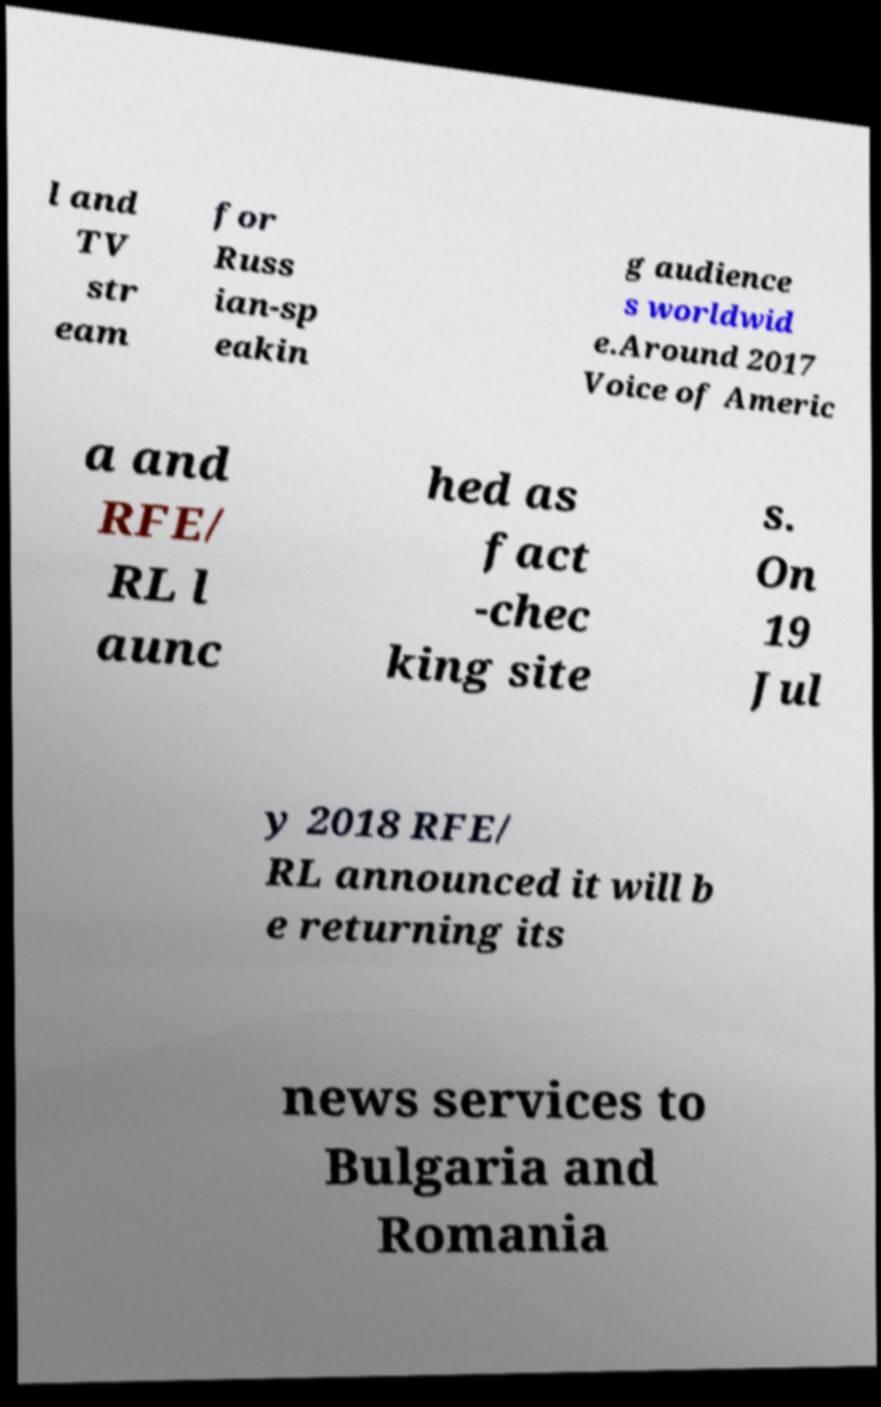Please read and relay the text visible in this image. What does it say? l and TV str eam for Russ ian-sp eakin g audience s worldwid e.Around 2017 Voice of Americ a and RFE/ RL l aunc hed as fact -chec king site s. On 19 Jul y 2018 RFE/ RL announced it will b e returning its news services to Bulgaria and Romania 